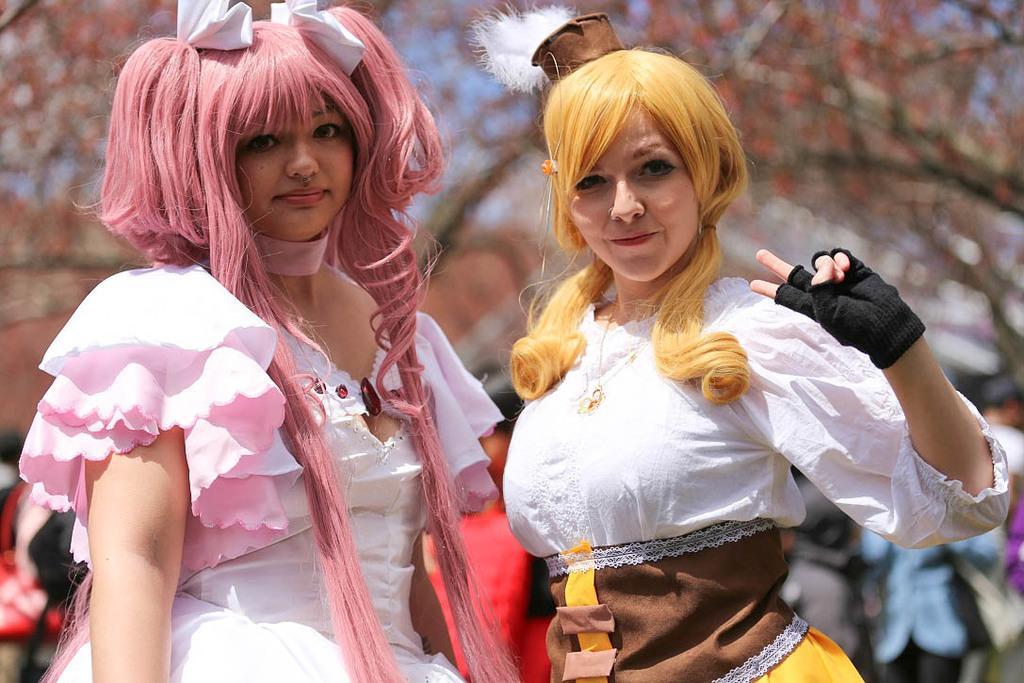Please provide a concise description of this image. In this picture we can see two women standing. We can see a few people at the back. It looks like there are a few plants visible in the background. Background is blurry. 